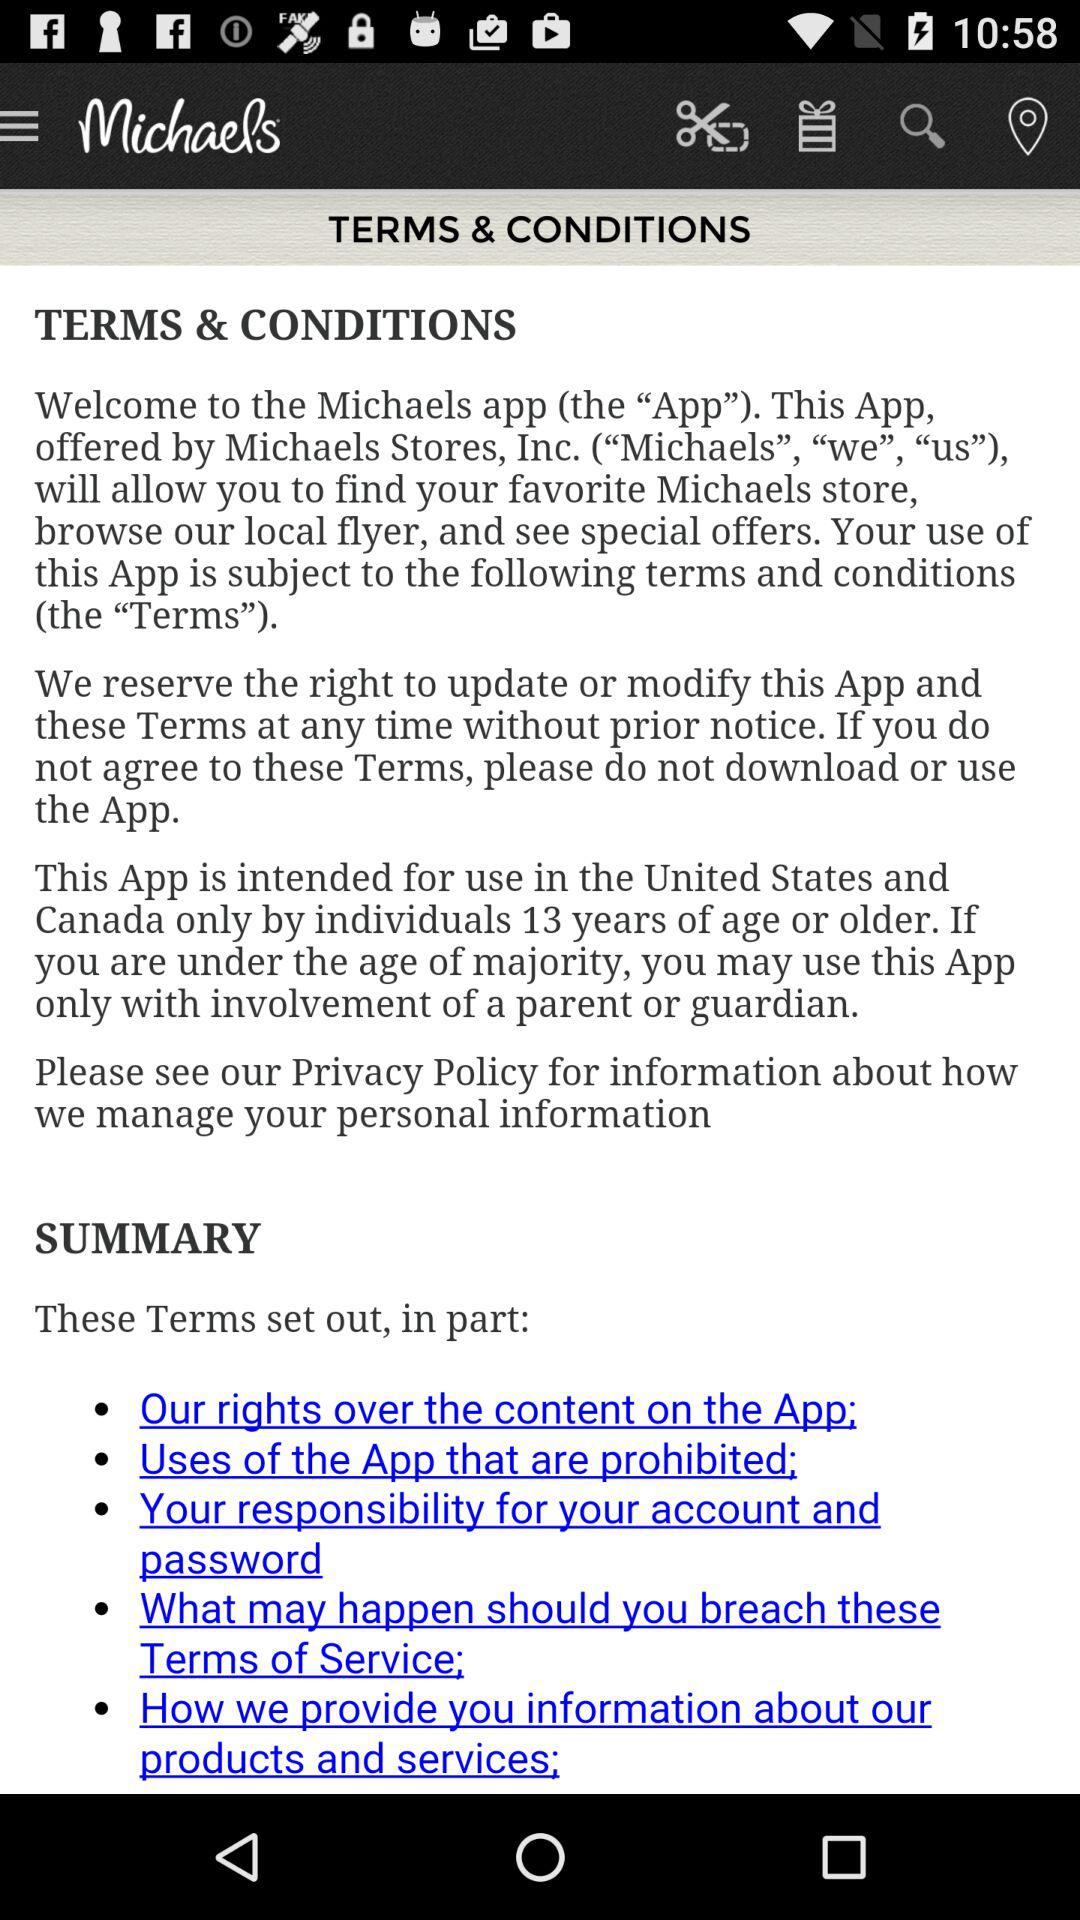In which countries is this app intended for use? The name of the country is the United States. 